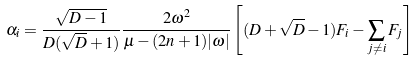Convert formula to latex. <formula><loc_0><loc_0><loc_500><loc_500>\alpha _ { i } = \frac { \sqrt { D - 1 } } { D ( \sqrt { D } + 1 ) } \frac { 2 \omega ^ { 2 } } { \mu - ( 2 n + 1 ) | \omega | } \left [ ( D + \sqrt { D } - 1 ) F _ { i } - \sum _ { j \neq i } F _ { j } \right ]</formula> 